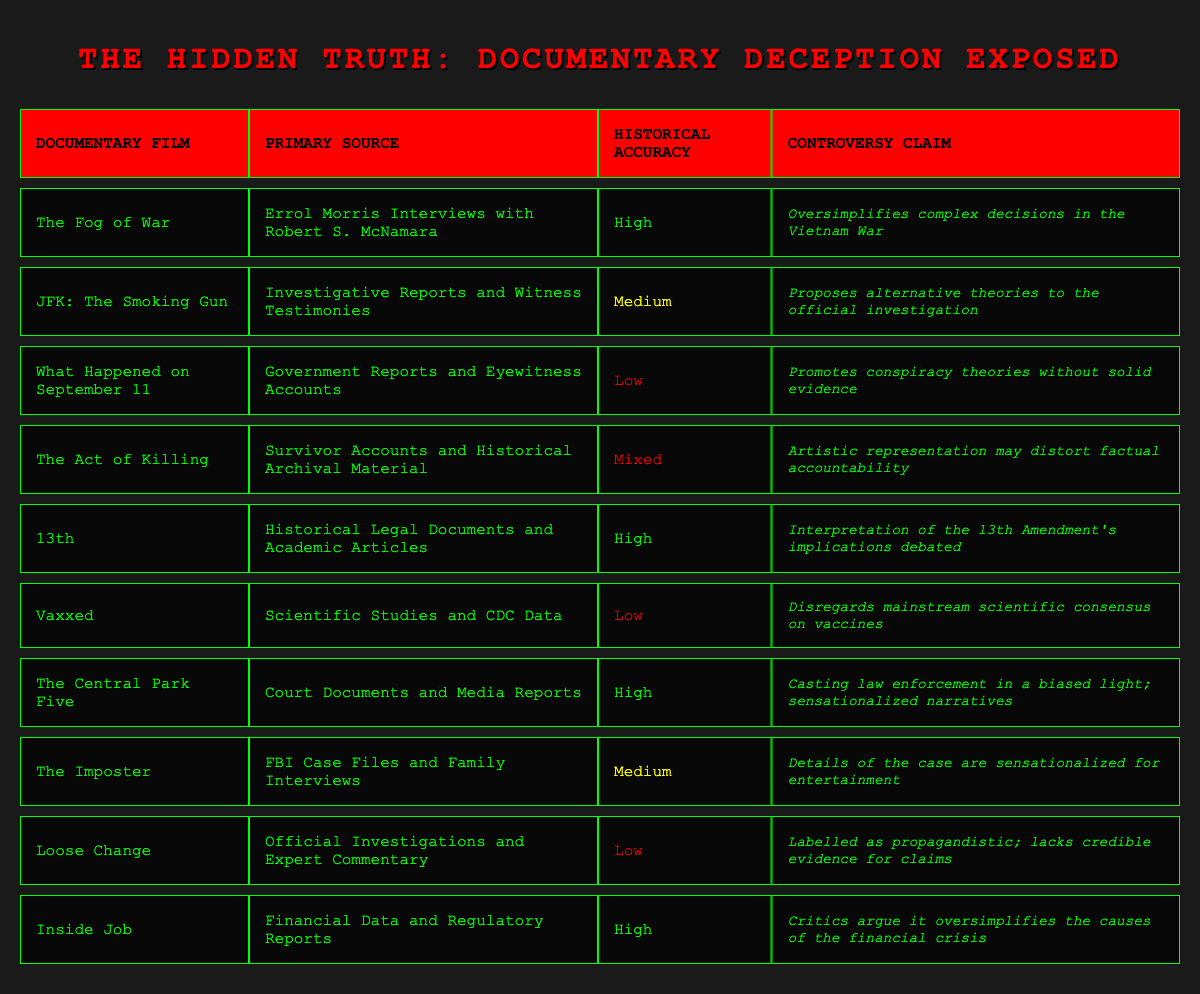What is the historical accuracy of "The Act of Killing"? "The Act of Killing" has a historical accuracy labeled as "Mixed" according to the table.
Answer: Mixed How many documentary films have a high historical accuracy? There are four documentary films with a high historical accuracy: "The Fog of War," "13th," "The Central Park Five," and "Inside Job."
Answer: 4 Is "Loose Change" classified as having high historical accuracy? "Loose Change" is classified as having low historical accuracy according to the table, which directly answers the question.
Answer: No What is the primary source used for "JFK: The Smoking Gun"? The primary source listed for "JFK: The Smoking Gun" is "Investigative Reports and Witness Testimonies" as seen in the table.
Answer: Investigative Reports and Witness Testimonies Which documentary film has the lowest historical accuracy? The documentary film with the lowest historical accuracy is "What Happened on September 11," which is labeled as low in the table.
Answer: What Happened on September 11 How many documentaries mention controversy regarding their historical accuracy? All ten documentaries listed mention some form of controversy regarding their historical accuracy, as each entry in the table lists a controversy claim.
Answer: 10 Which documentary film's claim suggests it oversimplifies complex decisions in the Vietnam War? "The Fog of War" is the documentary film that suggests it oversimplifies complex decisions in the Vietnam War based on the controversy claim provided in the table.
Answer: The Fog of War Are there more documentary films with low historical accuracy than those with medium accuracy? Yes, there are four documentaries with low historical accuracy ("What Happened on September 11," "Vaxxed," "Loose Change," and "The Act of Killing"), compared to three with medium accuracy ("JFK: The Smoking Gun," "The Imposter," and none other).
Answer: Yes What controversy claim is associated with the documentary "13th"? The controversy claim associated with "13th" is that the interpretation of the 13th Amendment's implications is debated, as stated in the table.
Answer: Interpretation of the 13th Amendment's implications debated 